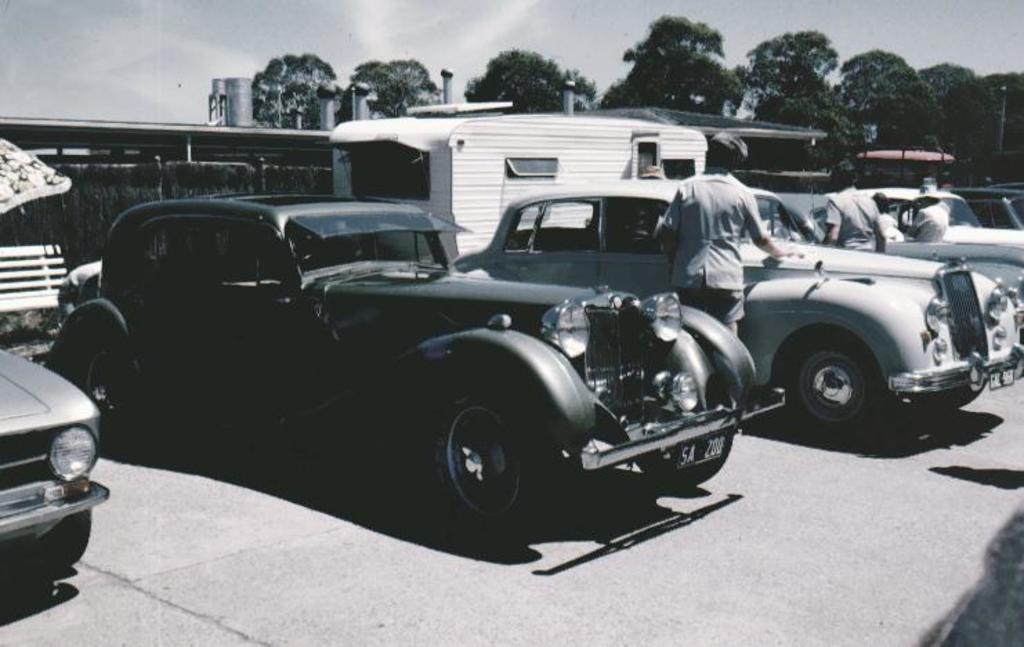In one or two sentences, can you explain what this image depicts? In this image we can see different color cars and some persons are standing near cars. On the top of the image we can see trees and the sky. 